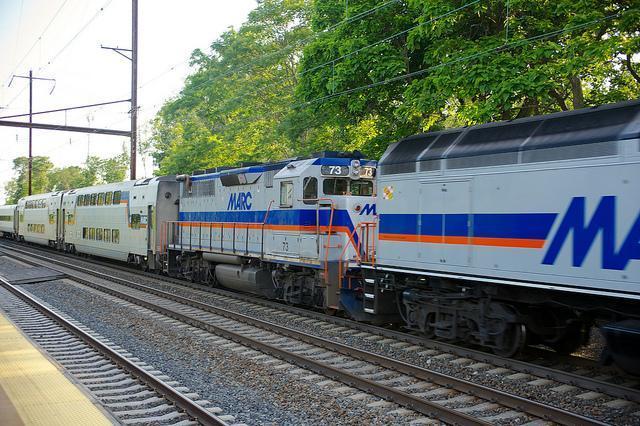How many tracks can you see?
Give a very brief answer. 3. 